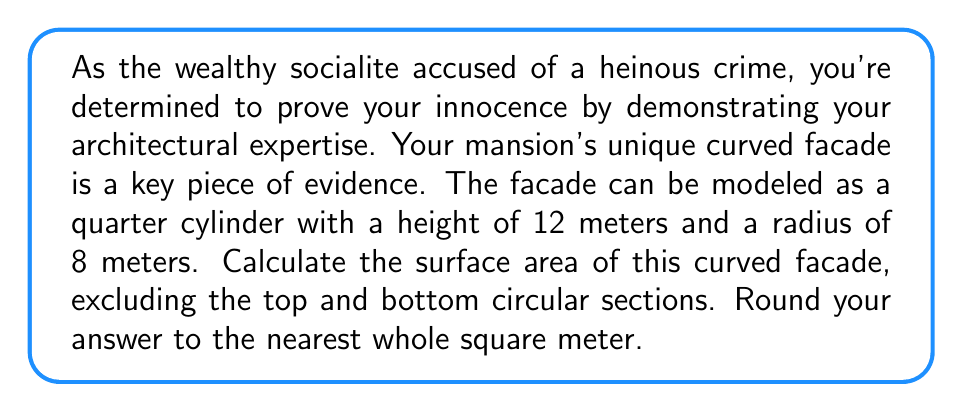Provide a solution to this math problem. To solve this problem, we need to use the formula for the surface area of a cylinder, but only consider a quarter of the lateral surface area since the facade is modeled as a quarter cylinder.

1. The formula for the lateral surface area of a full cylinder is:
   $$ A = 2\pi rh $$
   where $r$ is the radius and $h$ is the height.

2. Since we only need a quarter of this surface, we'll divide the formula by 4:
   $$ A_{quarter} = \frac{2\pi rh}{4} = \frac{\pi rh}{2} $$

3. Now, let's substitute the given values:
   $r = 8$ meters
   $h = 12$ meters

   $$ A_{quarter} = \frac{\pi \cdot 8 \cdot 12}{2} $$

4. Simplify:
   $$ A_{quarter} = \frac{96\pi}{2} = 48\pi $$

5. Calculate and round to the nearest whole square meter:
   $$ 48\pi \approx 150.80 \text{ m}^2 \approx 151 \text{ m}^2 $$

[asy]
import geometry;

size(200);
real r = 4;
real h = 6;

path p = arc((0,0), r, 0, 90);
draw(p);
draw((r,0)--(r,h));
draw(arc((0,h), r, 0, 90));
draw((0,0)--(0,h));

label("8 m", (r/2,0), S);
label("12 m", (r,-h/2), E);

draw((0,0)--(r,0), dashed);
draw((0,h)--(r,h), dashed);
[/asy]
Answer: The surface area of the curved mansion facade is approximately 151 square meters. 